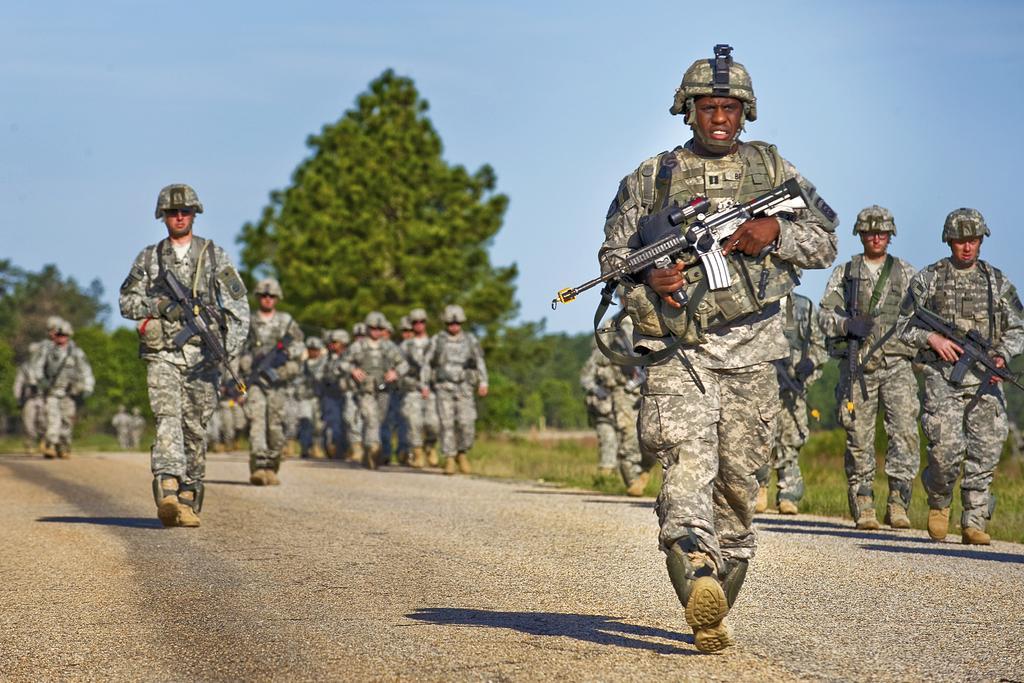Describe this image in one or two sentences. In this image there are so many military officers who are marching on the road by holding the guns. In the background there are trees. At the top there is sky. In the middle there is a military officer who is walking on the road by holding the gun. 